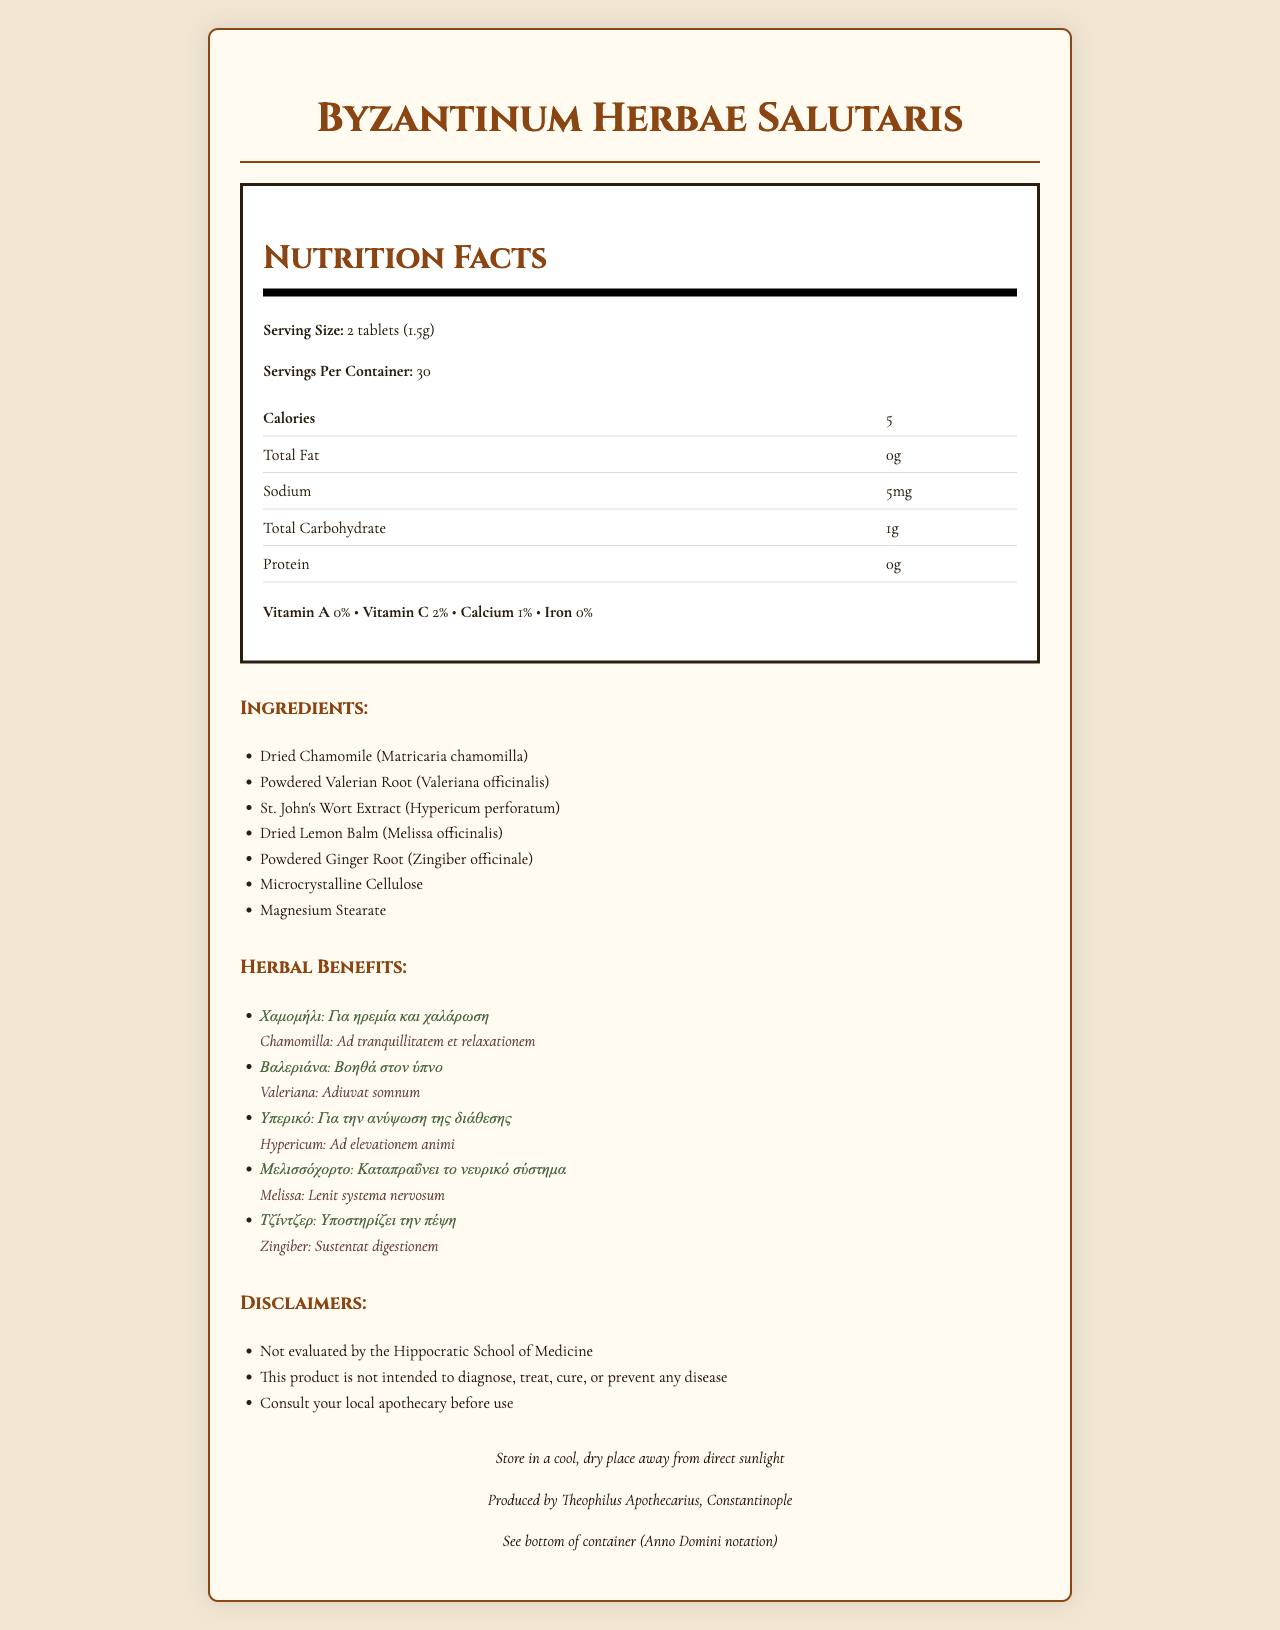How many servings per container are there? The document lists 30 servings per container under the nutrition facts section.
Answer: 30 What is the serving size? The serving size is clearly mentioned as 2 tablets (1.5g) in the nutrition facts section.
Answer: 2 tablets (1.5g) How many calories are in one serving? The nutrition facts specify that each serving contains 5 calories.
Answer: 5 calories What amount of sodium is in each serving? The nutrition facts section shows that each serving contains 5mg of sodium.
Answer: 5mg What are the ingredients in "Byzantinum Herbae Salutaris"? The ingredients are listed under the ingredients section of the document.
Answer: Dried Chamomile, Powdered Valerian Root, St. John's Wort Extract, Dried Lemon Balm, Powdered Ginger Root, Microcrystalline Cellulose, Magnesium Stearate What is the nutritional benefit of Chamomile according to the annotations? The Greek and Latin annotations state that Chamomile is for calmness and relaxation.
Answer: For calmness and relaxation (Χαμομήλι: Για ηρεμία και χαλάρωση / Chamomilla: Ad tranquillitatem et relaxationem) Which ingredient helps in digestion? According to the Greek and Latin annotations, Ginger helps in digestion.
Answer: Powdered Ginger Root (Τζίντζερ: Υποστηρίζει την πέψη / Zingiber: Sustentat digestionem) How should the product be stored? The storage instructions in the footer specify storage in a cool, dry place away from direct sunlight.
Answer: Store in a cool, dry place away from direct sunlight Who is the manufacturer of the product? The manufacturer information in the footer mentions Theophilus Apothecarius, located in Constantinople.
Answer: Theophilus Apothecarius, Constantinople By when does the product expire? The expiration date information suggests checking the bottom of the container for the expiration date in Anno Domini notation.
Answer: See bottom of container (Anno Domini notation) A. Chamomile
B. Valerian Root
C. St. John's Wort
D. Lemon Balm The annotations note that St. John's Wort (Υπερικό: Για την ανύψωση της διάθεσης / Hypericum: Ad elevationem animi) helps elevate mood.
Answer: C I. 0%
II. 1%
III. 2%
IV. 5% The nutrition facts section lists calcium content per serving as 1%.
Answer: II Is the product intended to diagnose, treat, cure, or prevent any disease? As per the disclaimers, the product is not intended to diagnose, treat, cure, or prevent any disease.
Answer: No Summarize the key information presented in the document. This summary includes details about the product's nutritional information, ingredients, the purpose of each herb, disclaimers, storage information, and manufacturer.
Answer: The document provides the nutrition facts, ingredients, annotations, disclaimers, storage instructions, manufacturer information, and expiration details for "Byzantinum Herbae Salutaris." It includes servings per container, serving size, calorie count, and nutrient values. Annotations in Greek and Latin describe the benefits of the herbs used. Disclaimers note that the product is not evaluated by the Hippocratic School of Medicine and is not meant to treat any disease. How many grams of protein are in one serving? The nutrition facts section indicates that there is no protein in one serving.
Answer: 0g Why should you consult a local apothecary before using the product? The disclaimers recommend consulting a local apothecary, highlighting the lack of formal evaluation by the Hippocratic School of Medicine.
Answer: This is suggested because the disclaimers indicate that the product's efficacy has not been evaluated, suggesting it may not have medically proven benefits. What type of cellulose does the product contain? The ingredient list includes microcrystalline cellulose.
Answer: Microcrystalline Cellulose From which city does the product originate? The footer states that the product is produced by Theophilus Apothecarius in Constantinople.
Answer: Constantinople Do the nutrition facts mention vitamin B content? The nutrition facts do not provide any information about vitamin B content.
Answer: Not enough information 